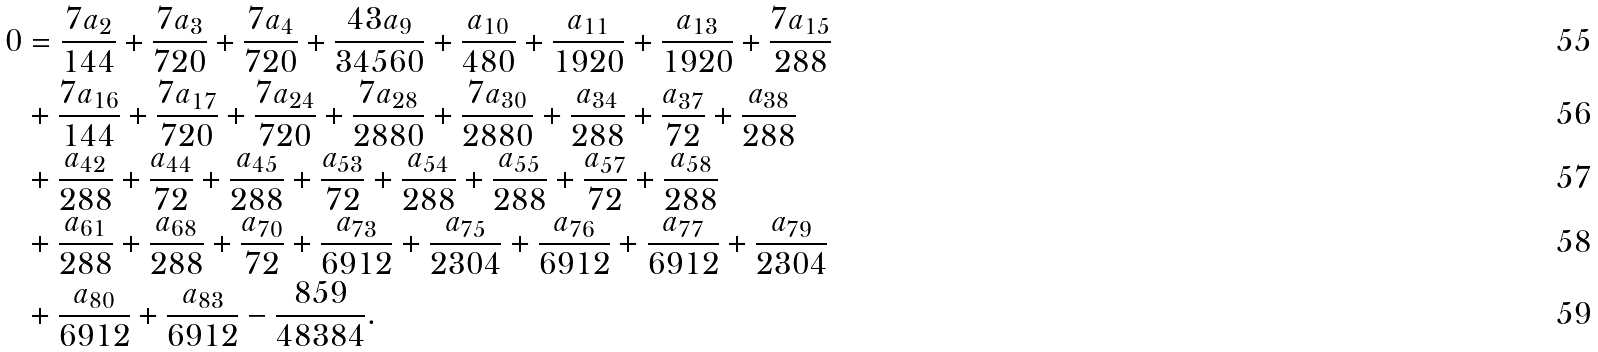Convert formula to latex. <formula><loc_0><loc_0><loc_500><loc_500>0 & = \frac { 7 a _ { 2 } } { 1 4 4 } + \frac { 7 a _ { 3 } } { 7 2 0 } + \frac { 7 a _ { 4 } } { 7 2 0 } + \frac { 4 3 a _ { 9 } } { 3 4 5 6 0 } + \frac { a _ { 1 0 } } { 4 8 0 } + \frac { a _ { 1 1 } } { 1 9 2 0 } + \frac { a _ { 1 3 } } { 1 9 2 0 } + \frac { 7 a _ { 1 5 } } { 2 8 8 } \\ & + \frac { 7 a _ { 1 6 } } { 1 4 4 } + \frac { 7 a _ { 1 7 } } { 7 2 0 } + \frac { 7 a _ { 2 4 } } { 7 2 0 } + \frac { 7 a _ { 2 8 } } { 2 8 8 0 } + \frac { 7 a _ { 3 0 } } { 2 8 8 0 } + \frac { a _ { 3 4 } } { 2 8 8 } + \frac { a _ { 3 7 } } { 7 2 } + \frac { a _ { 3 8 } } { 2 8 8 } \\ & + \frac { a _ { 4 2 } } { 2 8 8 } + \frac { a _ { 4 4 } } { 7 2 } + \frac { a _ { 4 5 } } { 2 8 8 } + \frac { a _ { 5 3 } } { 7 2 } + \frac { a _ { 5 4 } } { 2 8 8 } + \frac { a _ { 5 5 } } { 2 8 8 } + \frac { a _ { 5 7 } } { 7 2 } + \frac { a _ { 5 8 } } { 2 8 8 } \\ & + \frac { a _ { 6 1 } } { 2 8 8 } + \frac { a _ { 6 8 } } { 2 8 8 } + \frac { a _ { 7 0 } } { 7 2 } + \frac { a _ { 7 3 } } { 6 9 1 2 } + \frac { a _ { 7 5 } } { 2 3 0 4 } + \frac { a _ { 7 6 } } { 6 9 1 2 } + \frac { a _ { 7 7 } } { 6 9 1 2 } + \frac { a _ { 7 9 } } { 2 3 0 4 } \\ & + \frac { a _ { 8 0 } } { 6 9 1 2 } + \frac { a _ { 8 3 } } { 6 9 1 2 } - \frac { 8 5 9 } { 4 8 3 8 4 } .</formula> 